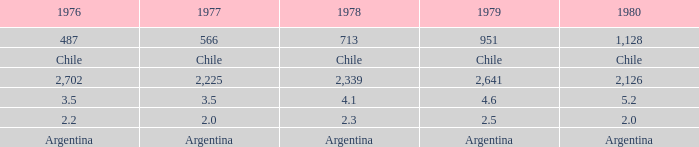What is 1977 when 1978 is 4.1? 3.5. 